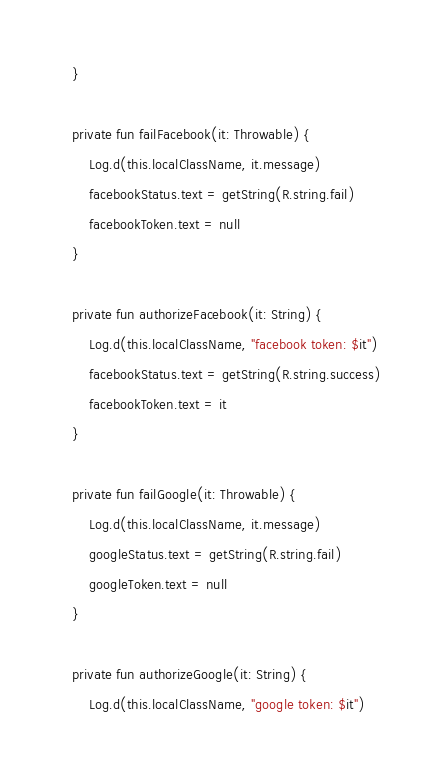<code> <loc_0><loc_0><loc_500><loc_500><_Kotlin_>    }

    private fun failFacebook(it: Throwable) {
        Log.d(this.localClassName, it.message)
        facebookStatus.text = getString(R.string.fail)
        facebookToken.text = null
    }

    private fun authorizeFacebook(it: String) {
        Log.d(this.localClassName, "facebook token: $it")
        facebookStatus.text = getString(R.string.success)
        facebookToken.text = it
    }

    private fun failGoogle(it: Throwable) {
        Log.d(this.localClassName, it.message)
        googleStatus.text = getString(R.string.fail)
        googleToken.text = null
    }

    private fun authorizeGoogle(it: String) {
        Log.d(this.localClassName, "google token: $it")</code> 